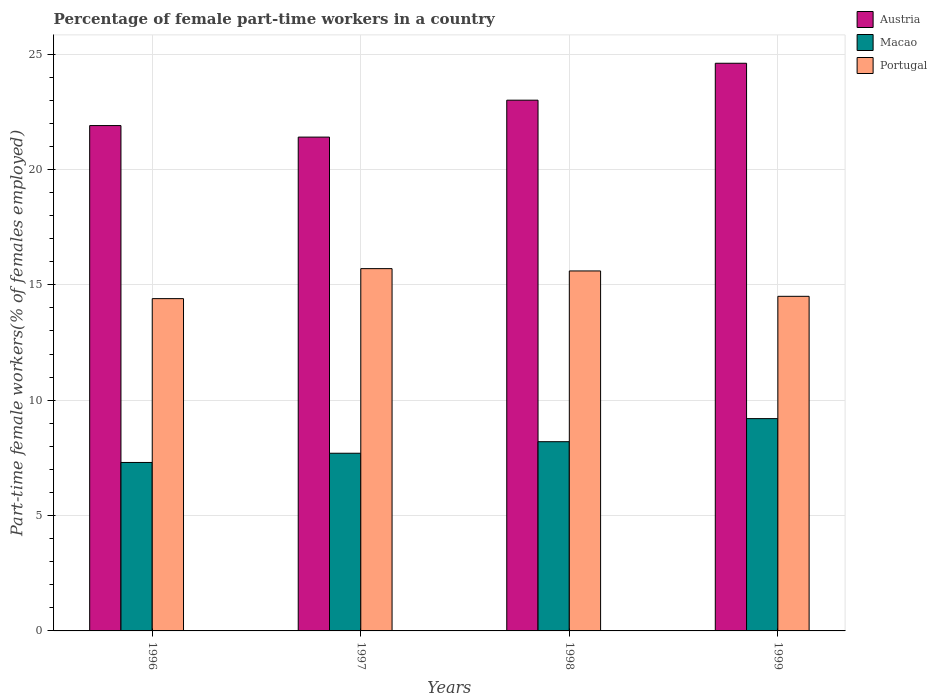How many groups of bars are there?
Make the answer very short. 4. Are the number of bars per tick equal to the number of legend labels?
Your response must be concise. Yes. How many bars are there on the 3rd tick from the left?
Provide a succinct answer. 3. What is the label of the 1st group of bars from the left?
Make the answer very short. 1996. In how many cases, is the number of bars for a given year not equal to the number of legend labels?
Your answer should be compact. 0. What is the percentage of female part-time workers in Portugal in 1996?
Provide a succinct answer. 14.4. Across all years, what is the maximum percentage of female part-time workers in Portugal?
Your response must be concise. 15.7. Across all years, what is the minimum percentage of female part-time workers in Portugal?
Your response must be concise. 14.4. In which year was the percentage of female part-time workers in Austria minimum?
Give a very brief answer. 1997. What is the total percentage of female part-time workers in Macao in the graph?
Offer a terse response. 32.4. What is the difference between the percentage of female part-time workers in Portugal in 1997 and that in 1999?
Provide a short and direct response. 1.2. What is the difference between the percentage of female part-time workers in Portugal in 1998 and the percentage of female part-time workers in Macao in 1996?
Provide a short and direct response. 8.3. What is the average percentage of female part-time workers in Macao per year?
Provide a short and direct response. 8.1. In the year 1999, what is the difference between the percentage of female part-time workers in Portugal and percentage of female part-time workers in Austria?
Offer a terse response. -10.1. In how many years, is the percentage of female part-time workers in Macao greater than 2 %?
Ensure brevity in your answer.  4. What is the ratio of the percentage of female part-time workers in Portugal in 1996 to that in 1999?
Provide a succinct answer. 0.99. Is the percentage of female part-time workers in Austria in 1996 less than that in 1997?
Ensure brevity in your answer.  No. What is the difference between the highest and the second highest percentage of female part-time workers in Austria?
Provide a short and direct response. 1.6. What is the difference between the highest and the lowest percentage of female part-time workers in Macao?
Your answer should be compact. 1.9. Is the sum of the percentage of female part-time workers in Portugal in 1996 and 1999 greater than the maximum percentage of female part-time workers in Macao across all years?
Your answer should be compact. Yes. What does the 2nd bar from the right in 1996 represents?
Offer a very short reply. Macao. Are all the bars in the graph horizontal?
Provide a short and direct response. No. What is the difference between two consecutive major ticks on the Y-axis?
Offer a very short reply. 5. Does the graph contain any zero values?
Give a very brief answer. No. How are the legend labels stacked?
Give a very brief answer. Vertical. What is the title of the graph?
Your answer should be compact. Percentage of female part-time workers in a country. Does "Morocco" appear as one of the legend labels in the graph?
Offer a terse response. No. What is the label or title of the X-axis?
Keep it short and to the point. Years. What is the label or title of the Y-axis?
Ensure brevity in your answer.  Part-time female workers(% of females employed). What is the Part-time female workers(% of females employed) of Austria in 1996?
Give a very brief answer. 21.9. What is the Part-time female workers(% of females employed) of Macao in 1996?
Offer a very short reply. 7.3. What is the Part-time female workers(% of females employed) in Portugal in 1996?
Offer a terse response. 14.4. What is the Part-time female workers(% of females employed) in Austria in 1997?
Your answer should be very brief. 21.4. What is the Part-time female workers(% of females employed) in Macao in 1997?
Offer a terse response. 7.7. What is the Part-time female workers(% of females employed) in Portugal in 1997?
Your response must be concise. 15.7. What is the Part-time female workers(% of females employed) in Macao in 1998?
Offer a very short reply. 8.2. What is the Part-time female workers(% of females employed) in Portugal in 1998?
Your answer should be very brief. 15.6. What is the Part-time female workers(% of females employed) of Austria in 1999?
Your response must be concise. 24.6. What is the Part-time female workers(% of females employed) of Macao in 1999?
Give a very brief answer. 9.2. Across all years, what is the maximum Part-time female workers(% of females employed) in Austria?
Ensure brevity in your answer.  24.6. Across all years, what is the maximum Part-time female workers(% of females employed) in Macao?
Provide a succinct answer. 9.2. Across all years, what is the maximum Part-time female workers(% of females employed) of Portugal?
Your answer should be compact. 15.7. Across all years, what is the minimum Part-time female workers(% of females employed) of Austria?
Your answer should be very brief. 21.4. Across all years, what is the minimum Part-time female workers(% of females employed) in Macao?
Offer a very short reply. 7.3. Across all years, what is the minimum Part-time female workers(% of females employed) of Portugal?
Keep it short and to the point. 14.4. What is the total Part-time female workers(% of females employed) in Austria in the graph?
Provide a succinct answer. 90.9. What is the total Part-time female workers(% of females employed) in Macao in the graph?
Make the answer very short. 32.4. What is the total Part-time female workers(% of females employed) in Portugal in the graph?
Make the answer very short. 60.2. What is the difference between the Part-time female workers(% of females employed) of Austria in 1996 and that in 1997?
Make the answer very short. 0.5. What is the difference between the Part-time female workers(% of females employed) in Macao in 1996 and that in 1997?
Make the answer very short. -0.4. What is the difference between the Part-time female workers(% of females employed) in Portugal in 1996 and that in 1998?
Give a very brief answer. -1.2. What is the difference between the Part-time female workers(% of females employed) of Austria in 1996 and that in 1999?
Ensure brevity in your answer.  -2.7. What is the difference between the Part-time female workers(% of females employed) of Portugal in 1996 and that in 1999?
Your response must be concise. -0.1. What is the difference between the Part-time female workers(% of females employed) of Macao in 1997 and that in 1998?
Offer a very short reply. -0.5. What is the difference between the Part-time female workers(% of females employed) of Austria in 1997 and that in 1999?
Make the answer very short. -3.2. What is the difference between the Part-time female workers(% of females employed) in Macao in 1997 and that in 1999?
Ensure brevity in your answer.  -1.5. What is the difference between the Part-time female workers(% of females employed) in Portugal in 1997 and that in 1999?
Provide a short and direct response. 1.2. What is the difference between the Part-time female workers(% of females employed) in Portugal in 1998 and that in 1999?
Give a very brief answer. 1.1. What is the difference between the Part-time female workers(% of females employed) in Austria in 1996 and the Part-time female workers(% of females employed) in Portugal in 1998?
Ensure brevity in your answer.  6.3. What is the difference between the Part-time female workers(% of females employed) in Macao in 1996 and the Part-time female workers(% of females employed) in Portugal in 1998?
Give a very brief answer. -8.3. What is the difference between the Part-time female workers(% of females employed) in Austria in 1996 and the Part-time female workers(% of females employed) in Portugal in 1999?
Your answer should be very brief. 7.4. What is the difference between the Part-time female workers(% of females employed) of Macao in 1996 and the Part-time female workers(% of females employed) of Portugal in 1999?
Your answer should be compact. -7.2. What is the difference between the Part-time female workers(% of females employed) of Austria in 1997 and the Part-time female workers(% of females employed) of Portugal in 1999?
Your answer should be compact. 6.9. What is the difference between the Part-time female workers(% of females employed) of Macao in 1997 and the Part-time female workers(% of females employed) of Portugal in 1999?
Your answer should be very brief. -6.8. What is the difference between the Part-time female workers(% of females employed) of Austria in 1998 and the Part-time female workers(% of females employed) of Macao in 1999?
Give a very brief answer. 13.8. What is the difference between the Part-time female workers(% of females employed) of Austria in 1998 and the Part-time female workers(% of females employed) of Portugal in 1999?
Make the answer very short. 8.5. What is the difference between the Part-time female workers(% of females employed) of Macao in 1998 and the Part-time female workers(% of females employed) of Portugal in 1999?
Offer a very short reply. -6.3. What is the average Part-time female workers(% of females employed) of Austria per year?
Your answer should be very brief. 22.73. What is the average Part-time female workers(% of females employed) in Macao per year?
Provide a succinct answer. 8.1. What is the average Part-time female workers(% of females employed) in Portugal per year?
Give a very brief answer. 15.05. In the year 1996, what is the difference between the Part-time female workers(% of females employed) of Austria and Part-time female workers(% of females employed) of Macao?
Ensure brevity in your answer.  14.6. In the year 1997, what is the difference between the Part-time female workers(% of females employed) of Austria and Part-time female workers(% of females employed) of Portugal?
Offer a very short reply. 5.7. In the year 1997, what is the difference between the Part-time female workers(% of females employed) in Macao and Part-time female workers(% of females employed) in Portugal?
Keep it short and to the point. -8. In the year 1998, what is the difference between the Part-time female workers(% of females employed) in Macao and Part-time female workers(% of females employed) in Portugal?
Give a very brief answer. -7.4. In the year 1999, what is the difference between the Part-time female workers(% of females employed) in Austria and Part-time female workers(% of females employed) in Portugal?
Make the answer very short. 10.1. In the year 1999, what is the difference between the Part-time female workers(% of females employed) of Macao and Part-time female workers(% of females employed) of Portugal?
Provide a succinct answer. -5.3. What is the ratio of the Part-time female workers(% of females employed) of Austria in 1996 to that in 1997?
Provide a short and direct response. 1.02. What is the ratio of the Part-time female workers(% of females employed) in Macao in 1996 to that in 1997?
Offer a very short reply. 0.95. What is the ratio of the Part-time female workers(% of females employed) of Portugal in 1996 to that in 1997?
Offer a terse response. 0.92. What is the ratio of the Part-time female workers(% of females employed) in Austria in 1996 to that in 1998?
Offer a terse response. 0.95. What is the ratio of the Part-time female workers(% of females employed) in Macao in 1996 to that in 1998?
Offer a terse response. 0.89. What is the ratio of the Part-time female workers(% of females employed) of Portugal in 1996 to that in 1998?
Ensure brevity in your answer.  0.92. What is the ratio of the Part-time female workers(% of females employed) in Austria in 1996 to that in 1999?
Provide a succinct answer. 0.89. What is the ratio of the Part-time female workers(% of females employed) in Macao in 1996 to that in 1999?
Offer a very short reply. 0.79. What is the ratio of the Part-time female workers(% of females employed) in Portugal in 1996 to that in 1999?
Give a very brief answer. 0.99. What is the ratio of the Part-time female workers(% of females employed) of Austria in 1997 to that in 1998?
Give a very brief answer. 0.93. What is the ratio of the Part-time female workers(% of females employed) in Macao in 1997 to that in 1998?
Make the answer very short. 0.94. What is the ratio of the Part-time female workers(% of females employed) in Portugal in 1997 to that in 1998?
Provide a short and direct response. 1.01. What is the ratio of the Part-time female workers(% of females employed) in Austria in 1997 to that in 1999?
Your answer should be compact. 0.87. What is the ratio of the Part-time female workers(% of females employed) of Macao in 1997 to that in 1999?
Offer a terse response. 0.84. What is the ratio of the Part-time female workers(% of females employed) of Portugal in 1997 to that in 1999?
Keep it short and to the point. 1.08. What is the ratio of the Part-time female workers(% of females employed) of Austria in 1998 to that in 1999?
Keep it short and to the point. 0.94. What is the ratio of the Part-time female workers(% of females employed) in Macao in 1998 to that in 1999?
Offer a very short reply. 0.89. What is the ratio of the Part-time female workers(% of females employed) in Portugal in 1998 to that in 1999?
Give a very brief answer. 1.08. What is the difference between the highest and the second highest Part-time female workers(% of females employed) in Austria?
Make the answer very short. 1.6. What is the difference between the highest and the lowest Part-time female workers(% of females employed) of Macao?
Your answer should be compact. 1.9. 